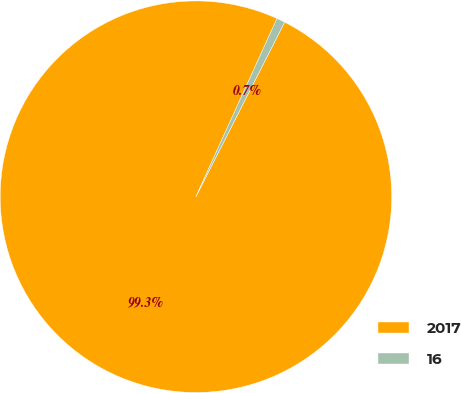Convert chart to OTSL. <chart><loc_0><loc_0><loc_500><loc_500><pie_chart><fcel>2017<fcel>16<nl><fcel>99.31%<fcel>0.69%<nl></chart> 